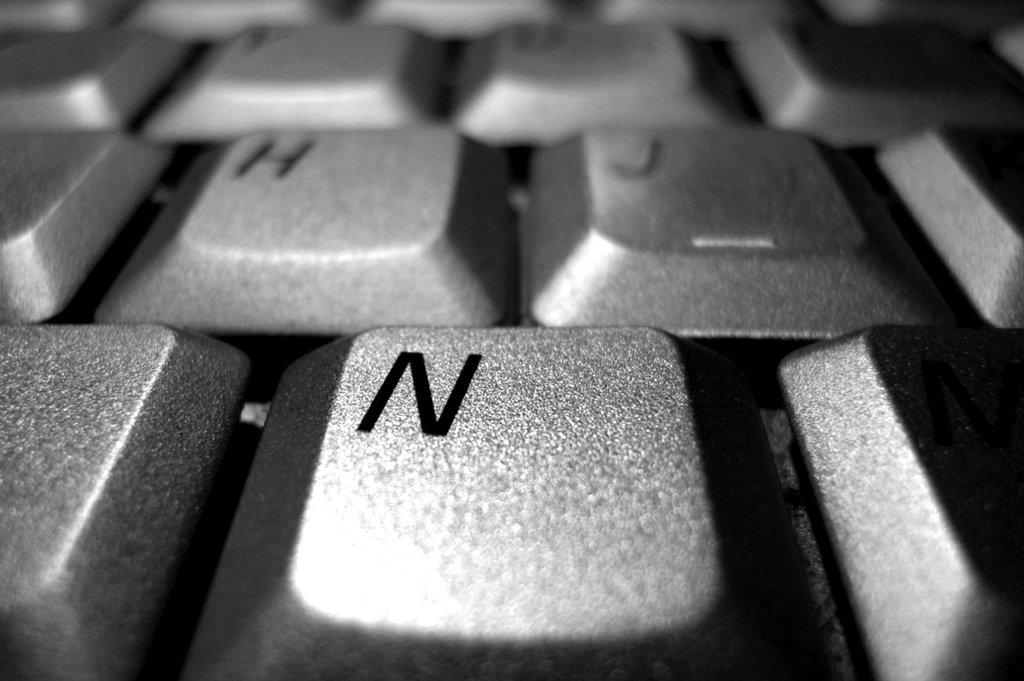<image>
Summarize the visual content of the image. keys n, h, j on a silver computer keyboard 